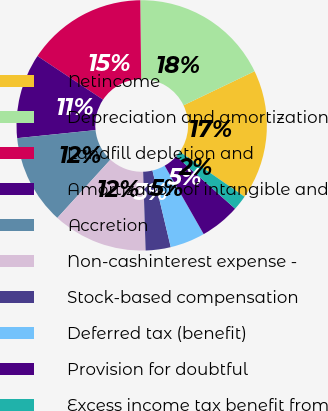<chart> <loc_0><loc_0><loc_500><loc_500><pie_chart><fcel>Netincome<fcel>Depreciation and amortization<fcel>Landfill depletion and<fcel>Amortization of intangible and<fcel>Accretion<fcel>Non-cashinterest expense -<fcel>Stock-based compensation<fcel>Deferred tax (benefit)<fcel>Provision for doubtful<fcel>Excess income tax benefit from<nl><fcel>16.77%<fcel>18.06%<fcel>15.48%<fcel>10.97%<fcel>11.61%<fcel>12.26%<fcel>3.23%<fcel>4.52%<fcel>5.16%<fcel>1.94%<nl></chart> 